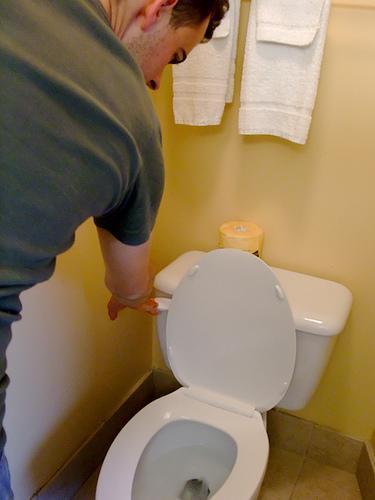How many men are visible?
Give a very brief answer. 1. How many toilets are shown?
Give a very brief answer. 1. 